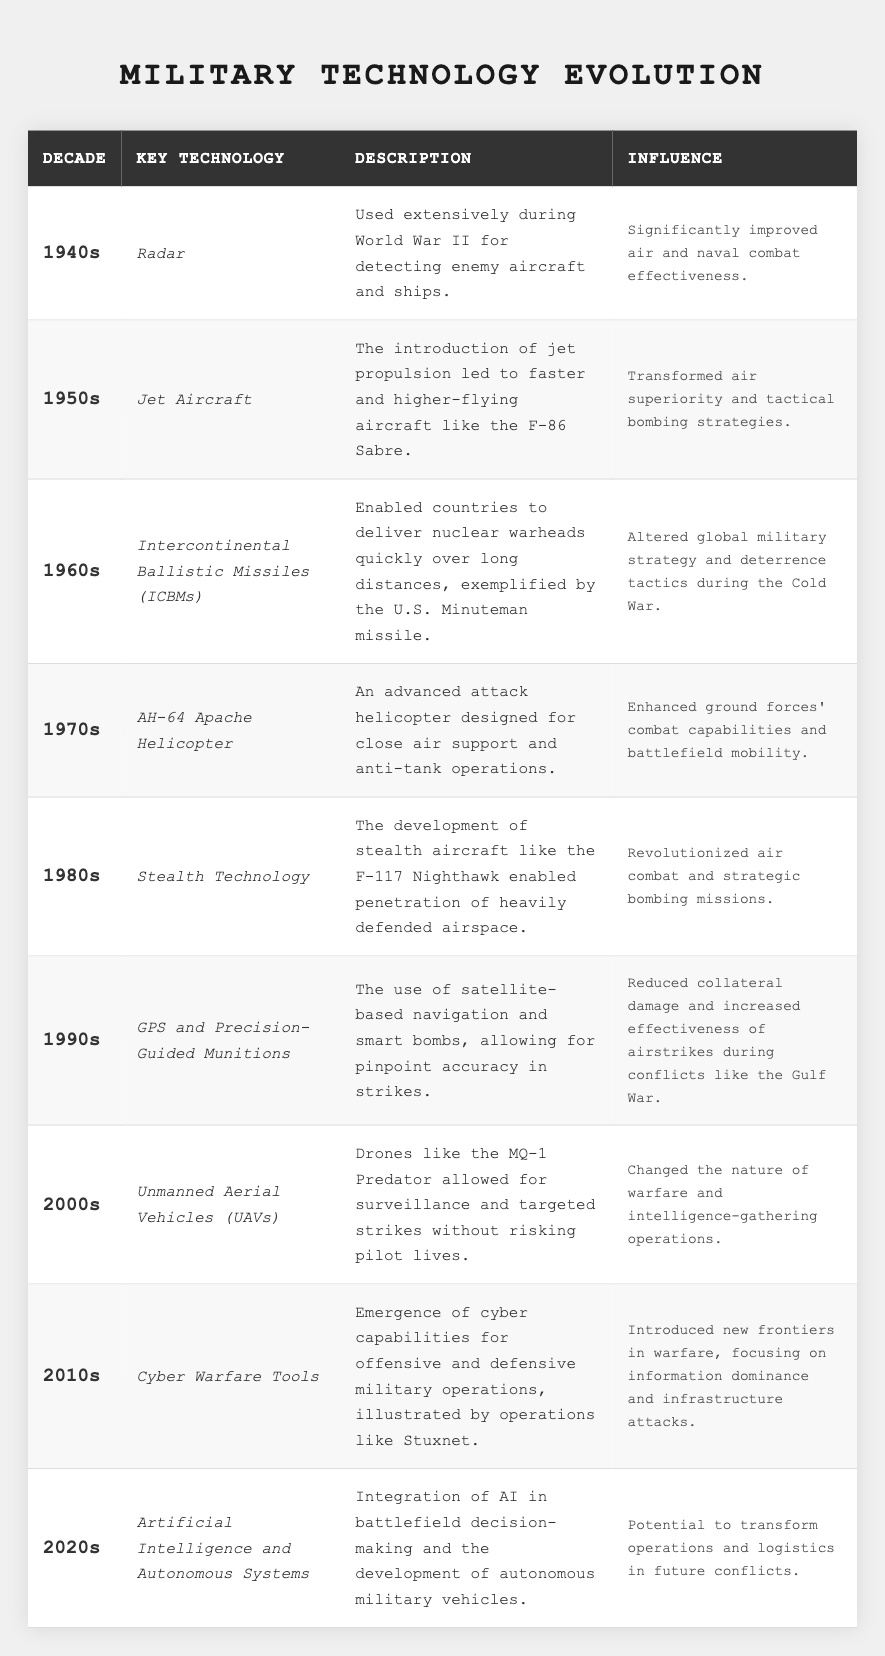What technology was introduced in the 1960s? The table indicates that the key technology introduced in the 1960s was Intercontinental Ballistic Missiles (ICBMs).
Answer: ICBMs Which decade saw the introduction of GPS and Precision-Guided Munitions? The table clearly states that GPS and Precision-Guided Munitions were introduced in the 1990s.
Answer: 1990s Did the 1980s introduce any new helicopter technology? According to the table, the 1980s did not introduce new helicopter technology; it focused on Stealth Technology instead.
Answer: No What was the influence of radar technology in the 1940s? The table mentions that radar significantly improved air and naval combat effectiveness during the 1940s.
Answer: Improved air and naval combat effectiveness What key technology was developed in the 2000s, and how did it change warfare? The table shows that Unmanned Aerial Vehicles (UAVs) were developed in the 2000s, changing warfare by allowing surveillance and targeted strikes without risking pilot lives.
Answer: UAVs changed warfare by allowing drones for surveillance without pilot risk Which decade had a significant focus on cyber warfare technology? The table indicates that the 2010s focused on Cyber Warfare Tools, evidenced by operations like Stuxnet.
Answer: 2010s What was the primary influence of stealth technology during the 1980s? The table states that stealth technology revolutionized air combat and strategic bombing missions in the 1980s.
Answer: Revolutionized air combat and strategic bombing If we consider all the technologies listed, how many were related to aerial combat? The technologies related to aerial combat include Radar, Jet Aircraft, Stealth Technology, and UAVs, which totals four technologies.
Answer: Four technologies Which technology mentioned had the greatest influence on global military strategy during the Cold War? The table specifies that ICBMs altered global military strategy and deterrence tactics during the Cold War, indicating it had the greatest influence.
Answer: ICBMs How has the focus of military technology shifted from the 1940s to the 2020s? A review of the table shows a shift from technologies aimed at detecting and engaging in direct combat (like Radar) to more sophisticated systems like AI and autonomous systems in the 2020s, highlighting an evolution towards automation and information dominance.
Answer: Shifted to automation and information dominance 